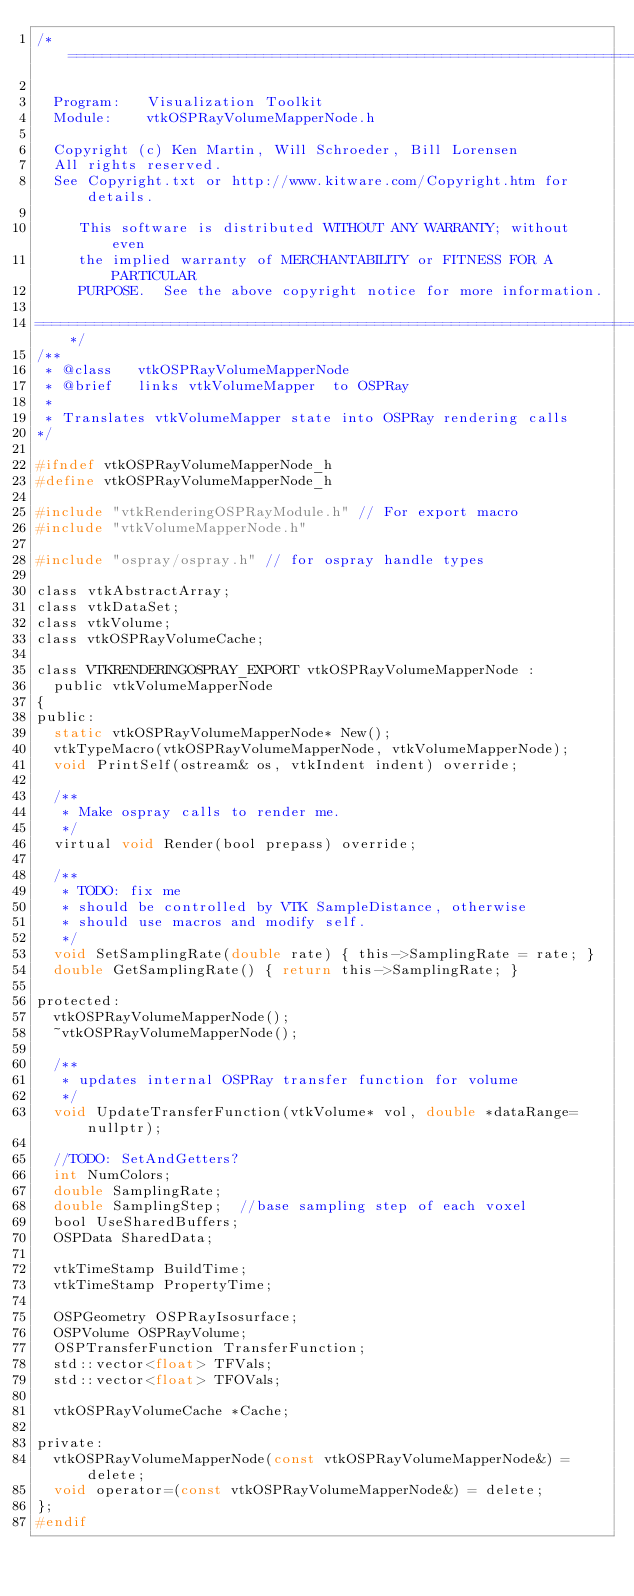<code> <loc_0><loc_0><loc_500><loc_500><_C_>/*=========================================================================

  Program:   Visualization Toolkit
  Module:    vtkOSPRayVolumeMapperNode.h

  Copyright (c) Ken Martin, Will Schroeder, Bill Lorensen
  All rights reserved.
  See Copyright.txt or http://www.kitware.com/Copyright.htm for details.

     This software is distributed WITHOUT ANY WARRANTY; without even
     the implied warranty of MERCHANTABILITY or FITNESS FOR A PARTICULAR
     PURPOSE.  See the above copyright notice for more information.

=========================================================================*/
/**
 * @class   vtkOSPRayVolumeMapperNode
 * @brief   links vtkVolumeMapper  to OSPRay
 *
 * Translates vtkVolumeMapper state into OSPRay rendering calls
*/

#ifndef vtkOSPRayVolumeMapperNode_h
#define vtkOSPRayVolumeMapperNode_h

#include "vtkRenderingOSPRayModule.h" // For export macro
#include "vtkVolumeMapperNode.h"

#include "ospray/ospray.h" // for ospray handle types

class vtkAbstractArray;
class vtkDataSet;
class vtkVolume;
class vtkOSPRayVolumeCache;

class VTKRENDERINGOSPRAY_EXPORT vtkOSPRayVolumeMapperNode :
  public vtkVolumeMapperNode
{
public:
  static vtkOSPRayVolumeMapperNode* New();
  vtkTypeMacro(vtkOSPRayVolumeMapperNode, vtkVolumeMapperNode);
  void PrintSelf(ostream& os, vtkIndent indent) override;

  /**
   * Make ospray calls to render me.
   */
  virtual void Render(bool prepass) override;

  /**
   * TODO: fix me
   * should be controlled by VTK SampleDistance, otherwise
   * should use macros and modify self.
   */
  void SetSamplingRate(double rate) { this->SamplingRate = rate; }
  double GetSamplingRate() { return this->SamplingRate; }

protected:
  vtkOSPRayVolumeMapperNode();
  ~vtkOSPRayVolumeMapperNode();

  /**
   * updates internal OSPRay transfer function for volume
   */
  void UpdateTransferFunction(vtkVolume* vol, double *dataRange=nullptr);

  //TODO: SetAndGetters?
  int NumColors;
  double SamplingRate;
  double SamplingStep;  //base sampling step of each voxel
  bool UseSharedBuffers;
  OSPData SharedData;

  vtkTimeStamp BuildTime;
  vtkTimeStamp PropertyTime;

  OSPGeometry OSPRayIsosurface;
  OSPVolume OSPRayVolume;
  OSPTransferFunction TransferFunction;
  std::vector<float> TFVals;
  std::vector<float> TFOVals;

  vtkOSPRayVolumeCache *Cache;

private:
  vtkOSPRayVolumeMapperNode(const vtkOSPRayVolumeMapperNode&) = delete;
  void operator=(const vtkOSPRayVolumeMapperNode&) = delete;
};
#endif
</code> 